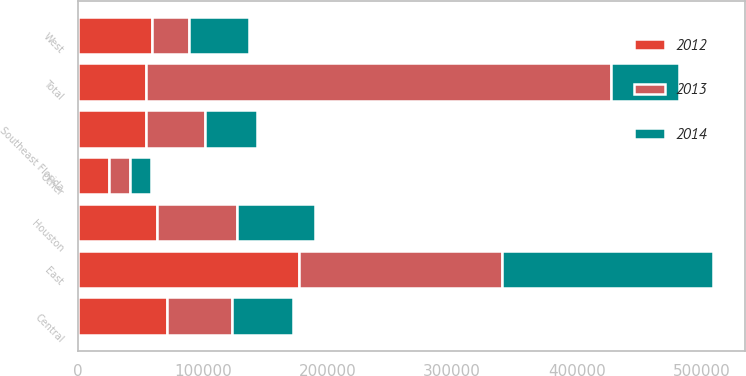Convert chart to OTSL. <chart><loc_0><loc_0><loc_500><loc_500><stacked_bar_chart><ecel><fcel>East<fcel>Central<fcel>West<fcel>Southeast Florida<fcel>Houston<fcel>Other<fcel>Total<nl><fcel>2012<fcel>176726<fcel>71533<fcel>59148<fcel>54529<fcel>62935<fcel>24286<fcel>54529<nl><fcel>2013<fcel>163039<fcel>51557<fcel>29542<fcel>47504<fcel>64216<fcel>17230<fcel>373088<nl><fcel>2014<fcel>169779<fcel>49028<fcel>48341<fcel>41529<fcel>62497<fcel>17050<fcel>54529<nl></chart> 